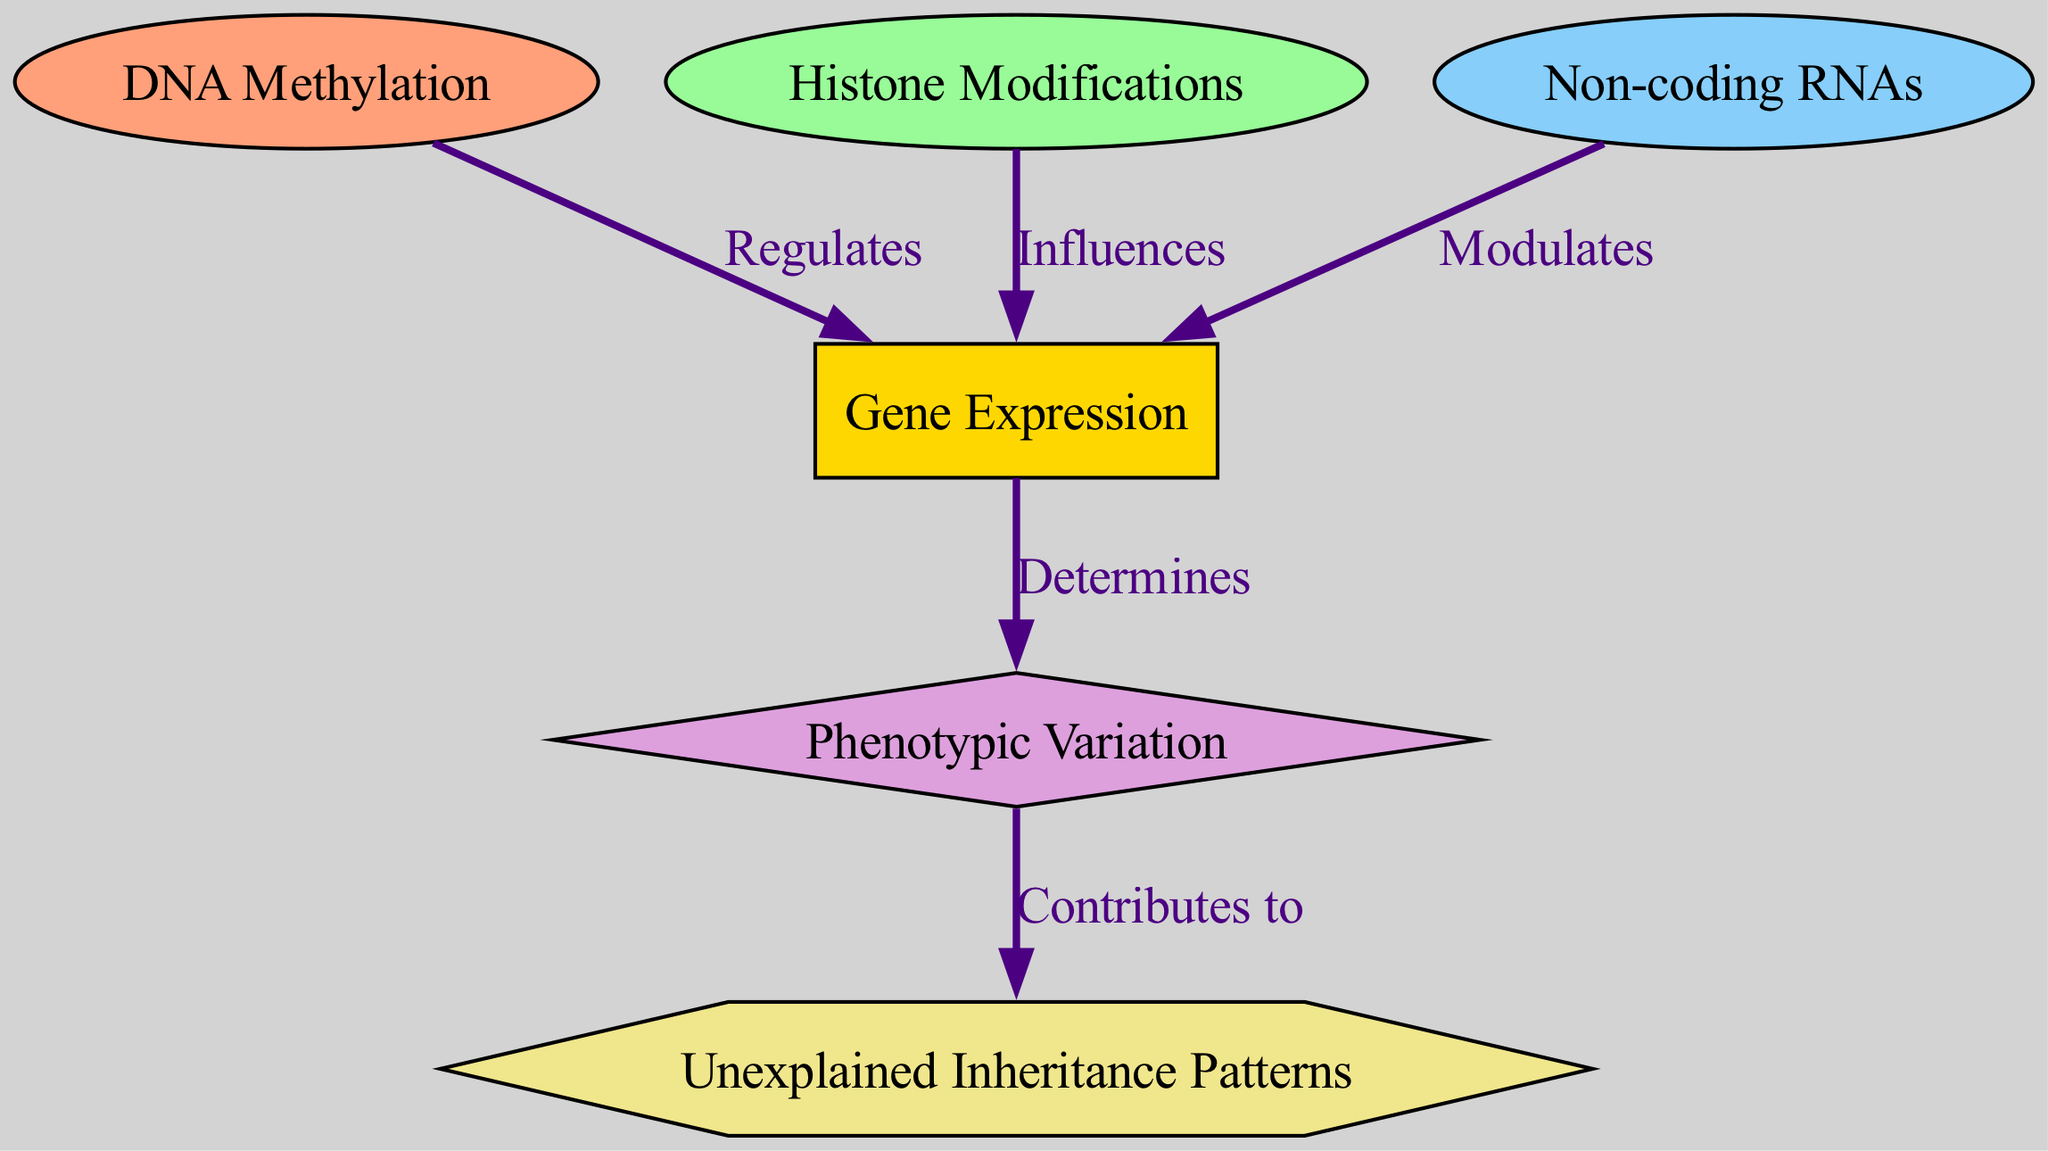What is the first node in the diagram? The first node listed in the diagram is "DNA Methylation," which is identified as the starting point for various processes illustrated in the schematic.
Answer: DNA Methylation How many nodes are present in the diagram? The diagram includes a total of six nodes, each representing different epigenetic modifications or phenomena connected to gene expression and inheritance.
Answer: 6 Which node receives a direct influence from Histone Modifications? "Gene Expression" is the node that Histone Modifications influences, clearly indicated by the directed edge labeled "Influences."
Answer: Gene Expression What is the relationship between Gene Expression and Phenotypic Variation? The relationship is that Gene Expression determines Phenotypic Variation, as shown by the edge labeled "Determines" connecting these two nodes.
Answer: Determines How do non-coding RNAs affect Gene Expression? Non-coding RNAs modulate Gene Expression, according to the edge between these two nodes labeled "Modulates," which illustrates their regulatory role in gene activity.
Answer: Modulates What contributes to Unexplained Inheritance Patterns? Phenotypic Variation contributes to Unexplained Inheritance Patterns, as evidenced by the directed edge labeled "Contributes to," which establishes a link between these two concepts.
Answer: Contributes to Which node directly regulates Gene Expression? "DNA Methylation" directly regulates Gene Expression, as indicated by the edge labeled "Regulates" that flows from DNA Methylation to Gene Expression.
Answer: Regulates What color represents Non-coding RNAs in the diagram? Non-coding RNAs are represented in a light blue color (#87CEFA), as specified by the node style that differentiates it visually from other nodes.
Answer: Light blue What is the shape of the Phenotypic Variation node? The Phenotypic Variation node is shaped like a diamond, which is distinct from the rectangles or ellipses used for other types of nodes in the diagram.
Answer: Diamond 